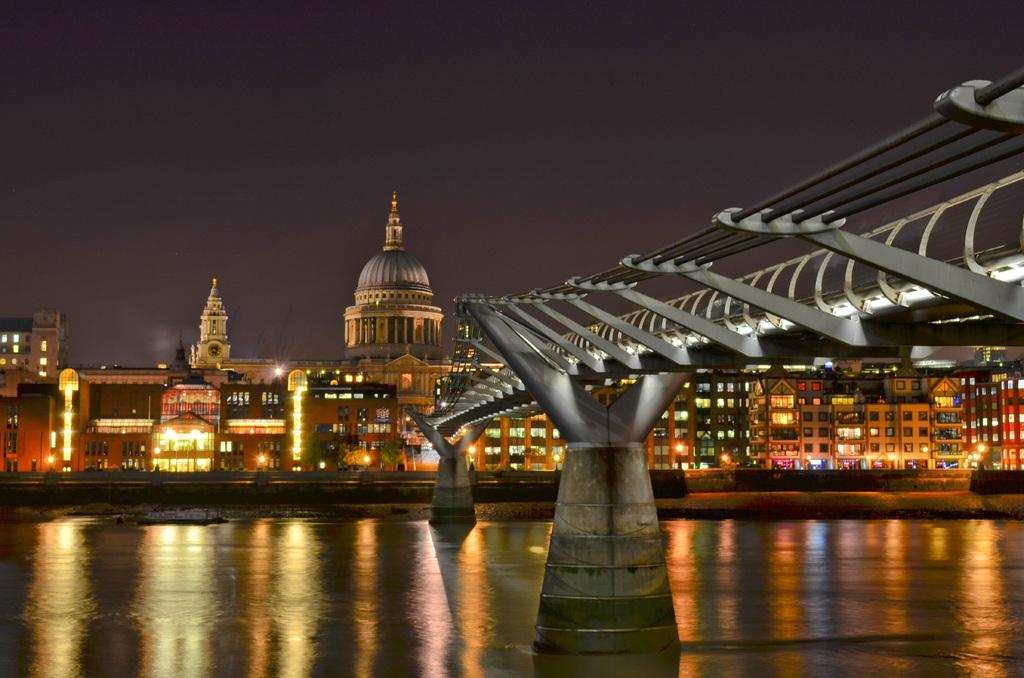What is the main structure in the image? There is a bridge in the image. What is the bridge positioned over? The bridge is over a lake. What other significant structure can be seen in the image? There is a big building in the image. What feature of the building is mentioned in the facts? The building has lights on it. How many maids are working in the building in the image? There is no mention of maids or any indication of their presence in the image. 